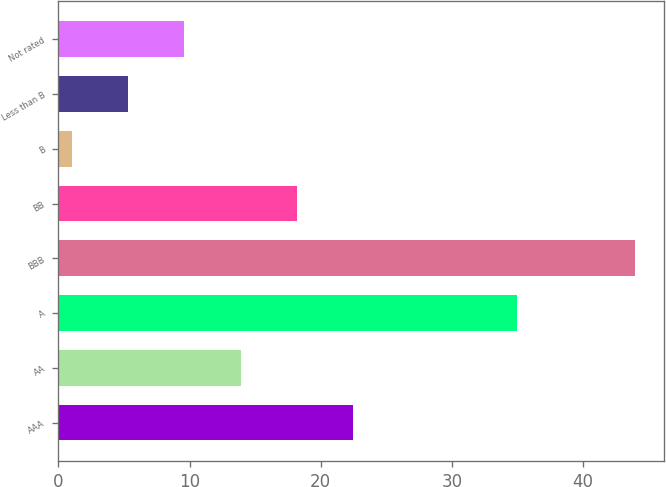Convert chart to OTSL. <chart><loc_0><loc_0><loc_500><loc_500><bar_chart><fcel>AAA<fcel>AA<fcel>A<fcel>BBB<fcel>BB<fcel>B<fcel>Less than B<fcel>Not rated<nl><fcel>22.5<fcel>13.9<fcel>35<fcel>44<fcel>18.2<fcel>1<fcel>5.3<fcel>9.6<nl></chart> 